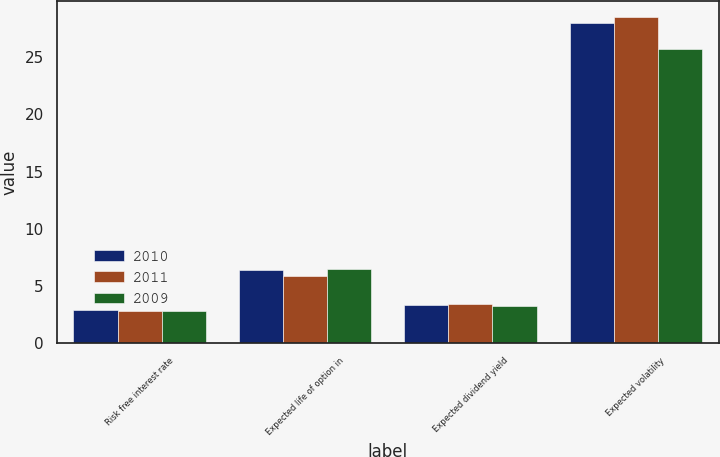Convert chart. <chart><loc_0><loc_0><loc_500><loc_500><stacked_bar_chart><ecel><fcel>Risk free interest rate<fcel>Expected life of option in<fcel>Expected dividend yield<fcel>Expected volatility<nl><fcel>2010<fcel>2.9<fcel>6.4<fcel>3.3<fcel>28<nl><fcel>2011<fcel>2.8<fcel>5.9<fcel>3.4<fcel>28.5<nl><fcel>2009<fcel>2.8<fcel>6.5<fcel>3.2<fcel>25.7<nl></chart> 